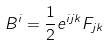<formula> <loc_0><loc_0><loc_500><loc_500>B ^ { i } = \frac { 1 } { 2 } e ^ { i j k } F _ { j k }</formula> 